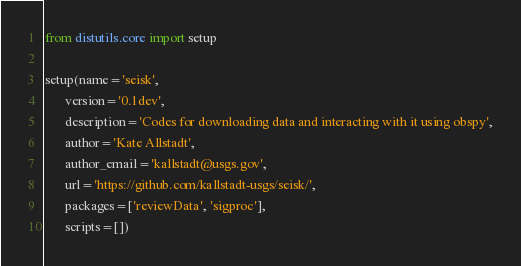Convert code to text. <code><loc_0><loc_0><loc_500><loc_500><_Python_>from distutils.core import setup

setup(name='seisk',
      version='0.1dev',
      description='Codes for downloading data and interacting with it using obspy',
      author='Kate Allstadt',
      author_email='kallstadt@usgs.gov',
      url='https://github.com/kallstadt-usgs/seisk/',
      packages=['reviewData', 'sigproc'],
      scripts=[])
</code> 